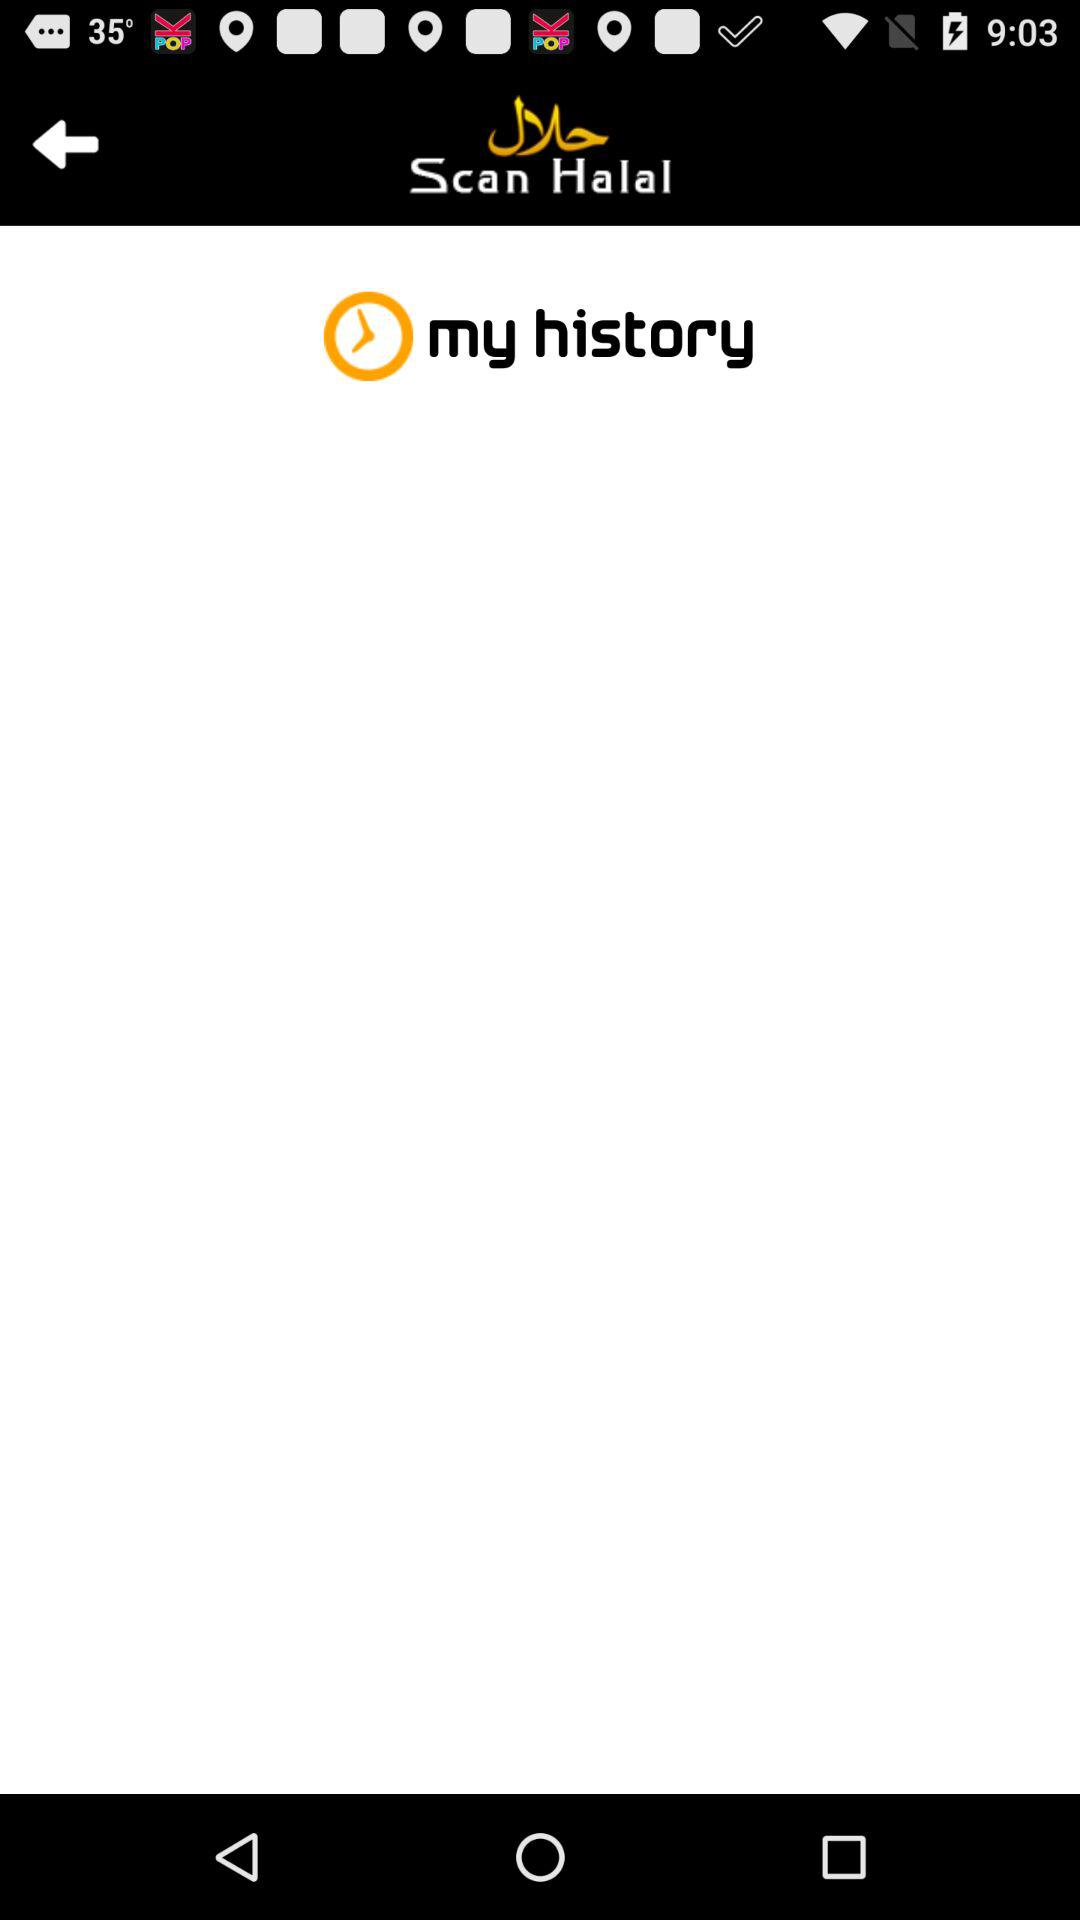What is the application name? The application name is "Scan Halal". 